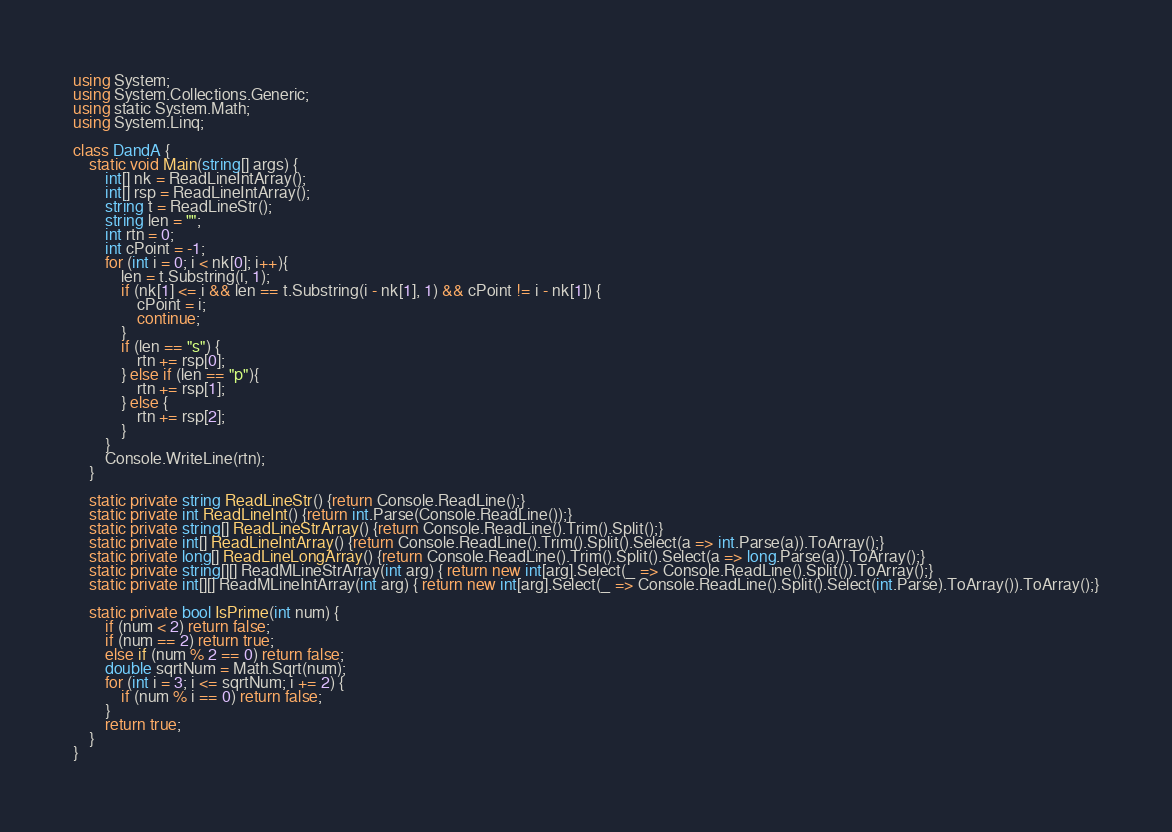Convert code to text. <code><loc_0><loc_0><loc_500><loc_500><_C#_>using System;
using System.Collections.Generic;
using static System.Math;
using System.Linq;
 
class DandA {
    static void Main(string[] args) {
        int[] nk = ReadLineIntArray();
        int[] rsp = ReadLineIntArray();
        string t = ReadLineStr();
        string len = "";
        int rtn = 0;
        int cPoint = -1;
        for (int i = 0; i < nk[0]; i++){
            len = t.Substring(i, 1);
            if (nk[1] <= i && len == t.Substring(i - nk[1], 1) && cPoint != i - nk[1]) {
                cPoint = i;
                continue;
            }
            if (len == "s") {
                rtn += rsp[0];
            } else if (len == "p"){
                rtn += rsp[1];
            } else {
                rtn += rsp[2];
            }
        }
        Console.WriteLine(rtn);
    }
  
    static private string ReadLineStr() {return Console.ReadLine();}
    static private int ReadLineInt() {return int.Parse(Console.ReadLine());}
    static private string[] ReadLineStrArray() {return Console.ReadLine().Trim().Split();}
    static private int[] ReadLineIntArray() {return Console.ReadLine().Trim().Split().Select(a => int.Parse(a)).ToArray();}
    static private long[] ReadLineLongArray() {return Console.ReadLine().Trim().Split().Select(a => long.Parse(a)).ToArray();}
    static private string[][] ReadMLineStrArray(int arg) { return new int[arg].Select(_ => Console.ReadLine().Split()).ToArray();}
    static private int[][] ReadMLineIntArray(int arg) { return new int[arg].Select(_ => Console.ReadLine().Split().Select(int.Parse).ToArray()).ToArray();}

    static private bool IsPrime(int num) {
        if (num < 2) return false;
        if (num == 2) return true;
        else if (num % 2 == 0) return false;
        double sqrtNum = Math.Sqrt(num);
        for (int i = 3; i <= sqrtNum; i += 2) {
            if (num % i == 0) return false;
        }
        return true;
    }
}</code> 